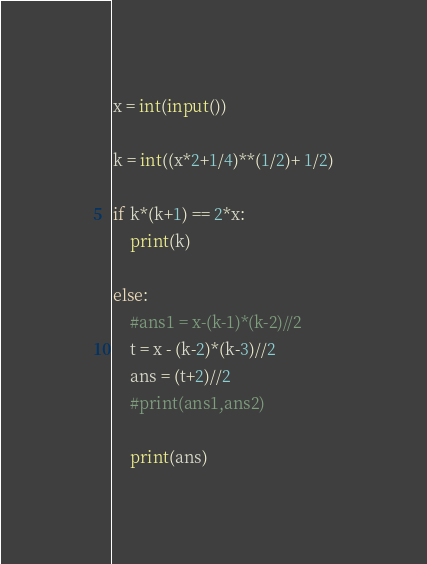Convert code to text. <code><loc_0><loc_0><loc_500><loc_500><_Python_>x = int(input())

k = int((x*2+1/4)**(1/2)+ 1/2)

if k*(k+1) == 2*x:
    print(k)

else:
    #ans1 = x-(k-1)*(k-2)//2
    t = x - (k-2)*(k-3)//2
    ans = (t+2)//2
    #print(ans1,ans2)

    print(ans)


</code> 